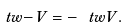Convert formula to latex. <formula><loc_0><loc_0><loc_500><loc_500>\ t w { - V } = - \ t w { V } .</formula> 